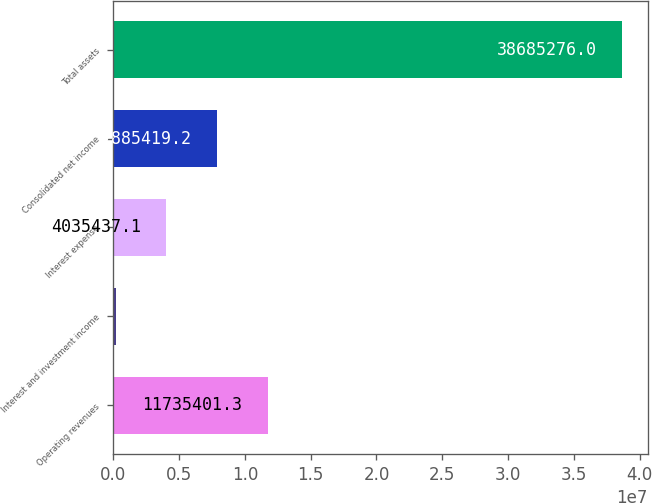Convert chart. <chart><loc_0><loc_0><loc_500><loc_500><bar_chart><fcel>Operating revenues<fcel>Interest and investment income<fcel>Interest expense<fcel>Consolidated net income<fcel>Total assets<nl><fcel>1.17354e+07<fcel>185455<fcel>4.03544e+06<fcel>7.88542e+06<fcel>3.86853e+07<nl></chart> 